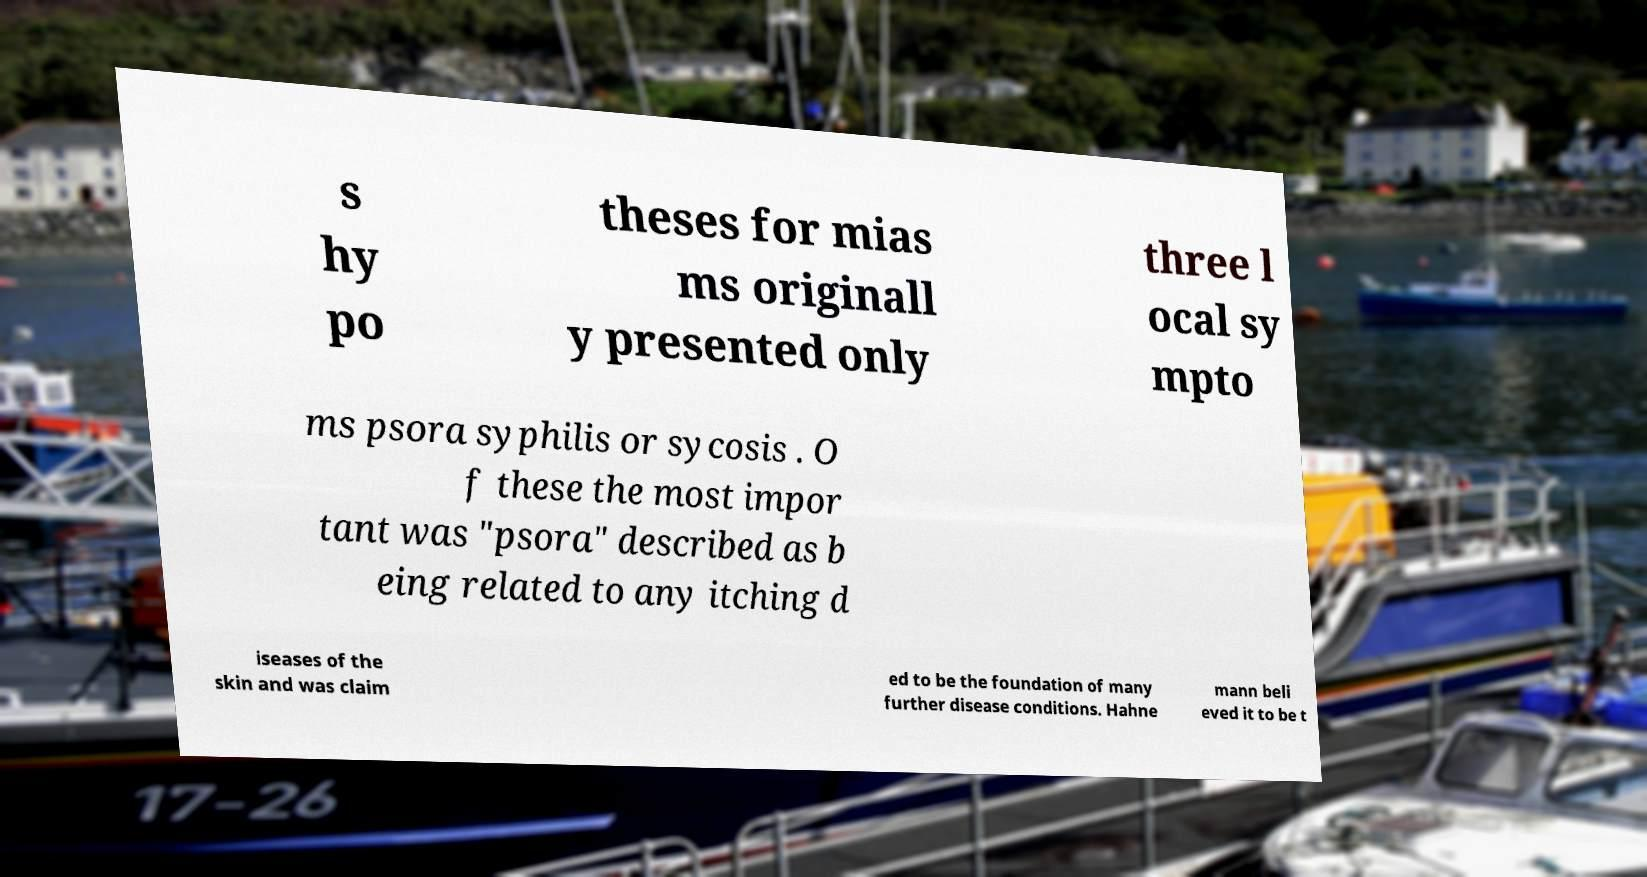There's text embedded in this image that I need extracted. Can you transcribe it verbatim? s hy po theses for mias ms originall y presented only three l ocal sy mpto ms psora syphilis or sycosis . O f these the most impor tant was "psora" described as b eing related to any itching d iseases of the skin and was claim ed to be the foundation of many further disease conditions. Hahne mann beli eved it to be t 